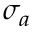<formula> <loc_0><loc_0><loc_500><loc_500>\sigma _ { a }</formula> 